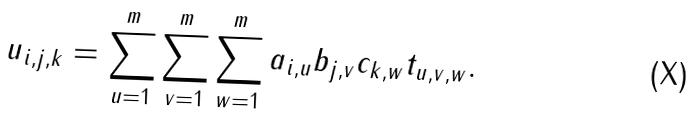<formula> <loc_0><loc_0><loc_500><loc_500>u _ { i , j , k } = \sum _ { u = 1 } ^ { m } \sum _ { v = 1 } ^ { m } \sum _ { w = 1 } ^ { m } a _ { i , u } b _ { j , v } c _ { k , w } t _ { u , v , w } .</formula> 